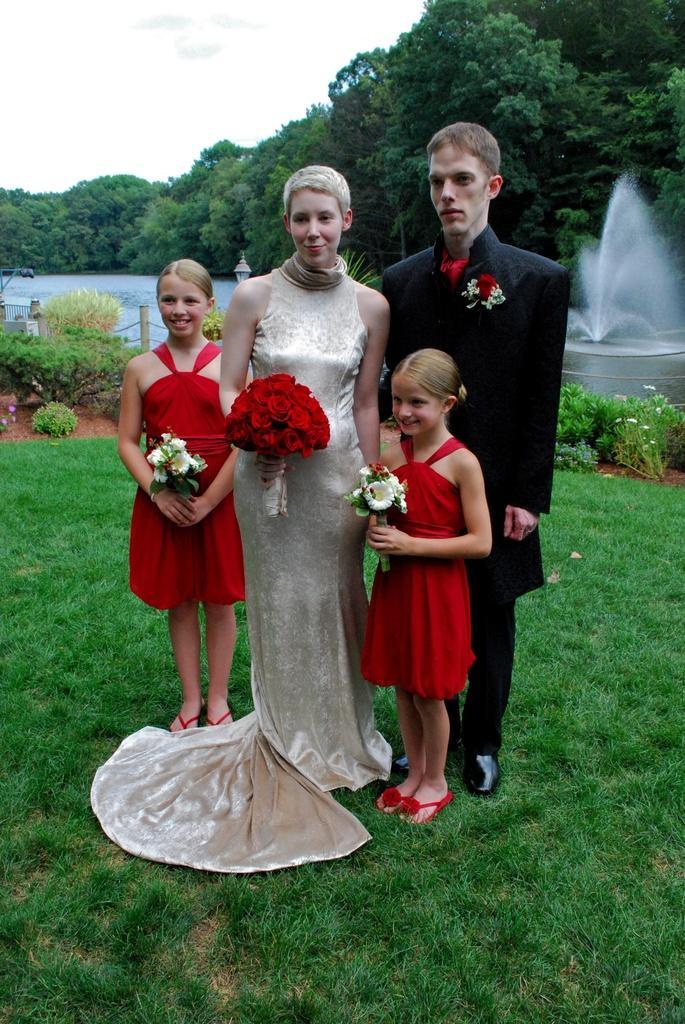Describe this image in one or two sentences. In this image we can see a group of people standing on the grass field. Some persons are holding flowers in their hands. In the background, we can see group of plants, fence, water fountain, a group of trees and the sky. 